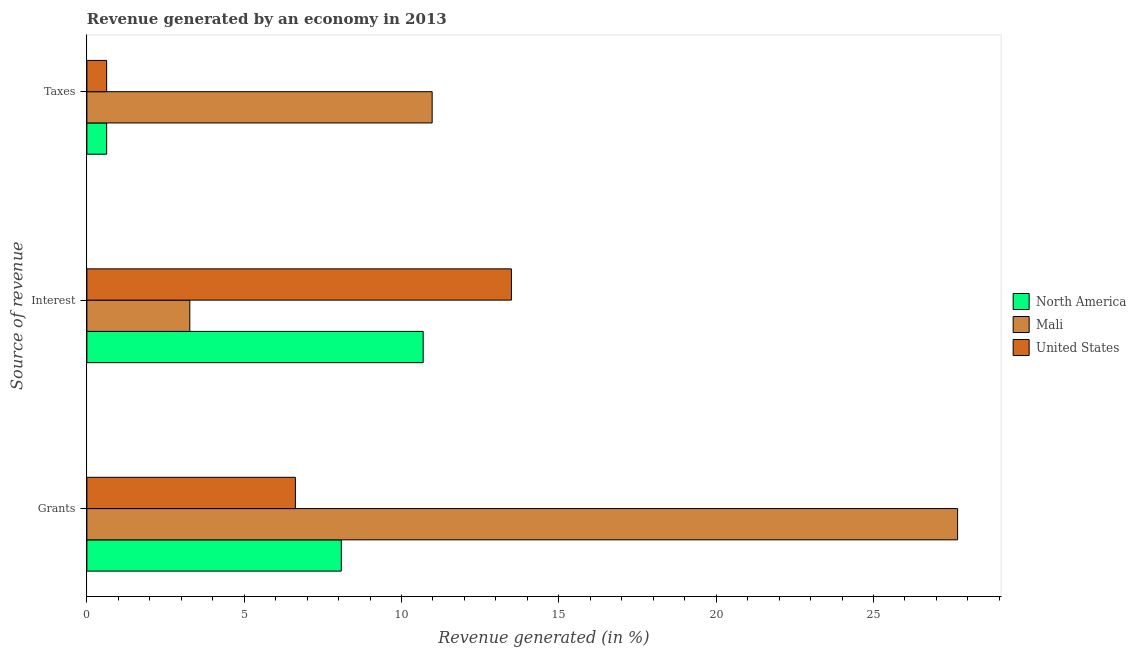Are the number of bars per tick equal to the number of legend labels?
Your answer should be compact. Yes. What is the label of the 1st group of bars from the top?
Ensure brevity in your answer.  Taxes. What is the percentage of revenue generated by grants in Mali?
Offer a very short reply. 27.67. Across all countries, what is the maximum percentage of revenue generated by interest?
Your answer should be compact. 13.49. Across all countries, what is the minimum percentage of revenue generated by interest?
Provide a succinct answer. 3.27. In which country was the percentage of revenue generated by interest maximum?
Make the answer very short. United States. What is the total percentage of revenue generated by interest in the graph?
Give a very brief answer. 27.45. What is the difference between the percentage of revenue generated by taxes in North America and that in United States?
Your answer should be very brief. 0. What is the difference between the percentage of revenue generated by interest in North America and the percentage of revenue generated by grants in Mali?
Your answer should be compact. -16.99. What is the average percentage of revenue generated by grants per country?
Give a very brief answer. 14.13. What is the difference between the percentage of revenue generated by interest and percentage of revenue generated by taxes in North America?
Make the answer very short. 10.06. In how many countries, is the percentage of revenue generated by grants greater than 28 %?
Your answer should be very brief. 0. What is the ratio of the percentage of revenue generated by grants in North America to that in Mali?
Make the answer very short. 0.29. What is the difference between the highest and the second highest percentage of revenue generated by interest?
Make the answer very short. 2.8. What is the difference between the highest and the lowest percentage of revenue generated by grants?
Your answer should be compact. 21.05. In how many countries, is the percentage of revenue generated by grants greater than the average percentage of revenue generated by grants taken over all countries?
Provide a short and direct response. 1. Is the sum of the percentage of revenue generated by grants in North America and Mali greater than the maximum percentage of revenue generated by taxes across all countries?
Keep it short and to the point. Yes. What does the 3rd bar from the top in Taxes represents?
Give a very brief answer. North America. What does the 2nd bar from the bottom in Interest represents?
Your answer should be very brief. Mali. How many bars are there?
Provide a short and direct response. 9. Are all the bars in the graph horizontal?
Your answer should be very brief. Yes. What is the difference between two consecutive major ticks on the X-axis?
Your response must be concise. 5. Are the values on the major ticks of X-axis written in scientific E-notation?
Provide a short and direct response. No. Does the graph contain any zero values?
Your answer should be very brief. No. Does the graph contain grids?
Provide a short and direct response. No. Where does the legend appear in the graph?
Keep it short and to the point. Center right. How many legend labels are there?
Make the answer very short. 3. How are the legend labels stacked?
Your response must be concise. Vertical. What is the title of the graph?
Your response must be concise. Revenue generated by an economy in 2013. What is the label or title of the X-axis?
Your answer should be very brief. Revenue generated (in %). What is the label or title of the Y-axis?
Provide a short and direct response. Source of revenue. What is the Revenue generated (in %) in North America in Grants?
Make the answer very short. 8.09. What is the Revenue generated (in %) of Mali in Grants?
Provide a succinct answer. 27.67. What is the Revenue generated (in %) of United States in Grants?
Keep it short and to the point. 6.63. What is the Revenue generated (in %) in North America in Interest?
Make the answer very short. 10.69. What is the Revenue generated (in %) of Mali in Interest?
Your answer should be very brief. 3.27. What is the Revenue generated (in %) of United States in Interest?
Keep it short and to the point. 13.49. What is the Revenue generated (in %) of North America in Taxes?
Your response must be concise. 0.63. What is the Revenue generated (in %) in Mali in Taxes?
Ensure brevity in your answer.  10.97. What is the Revenue generated (in %) of United States in Taxes?
Make the answer very short. 0.63. Across all Source of revenue, what is the maximum Revenue generated (in %) in North America?
Offer a terse response. 10.69. Across all Source of revenue, what is the maximum Revenue generated (in %) of Mali?
Your answer should be compact. 27.67. Across all Source of revenue, what is the maximum Revenue generated (in %) in United States?
Offer a terse response. 13.49. Across all Source of revenue, what is the minimum Revenue generated (in %) of North America?
Your response must be concise. 0.63. Across all Source of revenue, what is the minimum Revenue generated (in %) of Mali?
Provide a succinct answer. 3.27. Across all Source of revenue, what is the minimum Revenue generated (in %) of United States?
Provide a short and direct response. 0.63. What is the total Revenue generated (in %) of North America in the graph?
Give a very brief answer. 19.4. What is the total Revenue generated (in %) in Mali in the graph?
Provide a short and direct response. 41.92. What is the total Revenue generated (in %) of United States in the graph?
Your answer should be very brief. 20.75. What is the difference between the Revenue generated (in %) of North America in Grants and that in Interest?
Offer a terse response. -2.6. What is the difference between the Revenue generated (in %) of Mali in Grants and that in Interest?
Your answer should be very brief. 24.4. What is the difference between the Revenue generated (in %) of United States in Grants and that in Interest?
Offer a very short reply. -6.87. What is the difference between the Revenue generated (in %) of North America in Grants and that in Taxes?
Provide a short and direct response. 7.46. What is the difference between the Revenue generated (in %) in Mali in Grants and that in Taxes?
Your answer should be very brief. 16.7. What is the difference between the Revenue generated (in %) of United States in Grants and that in Taxes?
Offer a very short reply. 6. What is the difference between the Revenue generated (in %) in North America in Interest and that in Taxes?
Your answer should be compact. 10.06. What is the difference between the Revenue generated (in %) of Mali in Interest and that in Taxes?
Ensure brevity in your answer.  -7.7. What is the difference between the Revenue generated (in %) of United States in Interest and that in Taxes?
Keep it short and to the point. 12.86. What is the difference between the Revenue generated (in %) in North America in Grants and the Revenue generated (in %) in Mali in Interest?
Your answer should be very brief. 4.81. What is the difference between the Revenue generated (in %) of North America in Grants and the Revenue generated (in %) of United States in Interest?
Your response must be concise. -5.41. What is the difference between the Revenue generated (in %) in Mali in Grants and the Revenue generated (in %) in United States in Interest?
Your response must be concise. 14.18. What is the difference between the Revenue generated (in %) in North America in Grants and the Revenue generated (in %) in Mali in Taxes?
Your answer should be compact. -2.89. What is the difference between the Revenue generated (in %) of North America in Grants and the Revenue generated (in %) of United States in Taxes?
Your answer should be compact. 7.46. What is the difference between the Revenue generated (in %) in Mali in Grants and the Revenue generated (in %) in United States in Taxes?
Give a very brief answer. 27.05. What is the difference between the Revenue generated (in %) in North America in Interest and the Revenue generated (in %) in Mali in Taxes?
Keep it short and to the point. -0.28. What is the difference between the Revenue generated (in %) of North America in Interest and the Revenue generated (in %) of United States in Taxes?
Keep it short and to the point. 10.06. What is the difference between the Revenue generated (in %) in Mali in Interest and the Revenue generated (in %) in United States in Taxes?
Keep it short and to the point. 2.64. What is the average Revenue generated (in %) of North America per Source of revenue?
Your answer should be compact. 6.47. What is the average Revenue generated (in %) in Mali per Source of revenue?
Your answer should be very brief. 13.97. What is the average Revenue generated (in %) in United States per Source of revenue?
Your answer should be compact. 6.92. What is the difference between the Revenue generated (in %) in North America and Revenue generated (in %) in Mali in Grants?
Provide a short and direct response. -19.59. What is the difference between the Revenue generated (in %) of North America and Revenue generated (in %) of United States in Grants?
Your response must be concise. 1.46. What is the difference between the Revenue generated (in %) of Mali and Revenue generated (in %) of United States in Grants?
Provide a succinct answer. 21.05. What is the difference between the Revenue generated (in %) in North America and Revenue generated (in %) in Mali in Interest?
Your answer should be very brief. 7.42. What is the difference between the Revenue generated (in %) of North America and Revenue generated (in %) of United States in Interest?
Offer a terse response. -2.8. What is the difference between the Revenue generated (in %) of Mali and Revenue generated (in %) of United States in Interest?
Your response must be concise. -10.22. What is the difference between the Revenue generated (in %) of North America and Revenue generated (in %) of Mali in Taxes?
Give a very brief answer. -10.34. What is the difference between the Revenue generated (in %) in Mali and Revenue generated (in %) in United States in Taxes?
Offer a very short reply. 10.34. What is the ratio of the Revenue generated (in %) in North America in Grants to that in Interest?
Provide a succinct answer. 0.76. What is the ratio of the Revenue generated (in %) in Mali in Grants to that in Interest?
Offer a very short reply. 8.46. What is the ratio of the Revenue generated (in %) of United States in Grants to that in Interest?
Provide a succinct answer. 0.49. What is the ratio of the Revenue generated (in %) of North America in Grants to that in Taxes?
Provide a short and direct response. 12.86. What is the ratio of the Revenue generated (in %) in Mali in Grants to that in Taxes?
Your response must be concise. 2.52. What is the ratio of the Revenue generated (in %) in United States in Grants to that in Taxes?
Offer a terse response. 10.54. What is the ratio of the Revenue generated (in %) of North America in Interest to that in Taxes?
Ensure brevity in your answer.  17. What is the ratio of the Revenue generated (in %) of Mali in Interest to that in Taxes?
Keep it short and to the point. 0.3. What is the ratio of the Revenue generated (in %) of United States in Interest to that in Taxes?
Your answer should be very brief. 21.46. What is the difference between the highest and the second highest Revenue generated (in %) in North America?
Offer a terse response. 2.6. What is the difference between the highest and the second highest Revenue generated (in %) in Mali?
Your response must be concise. 16.7. What is the difference between the highest and the second highest Revenue generated (in %) in United States?
Your answer should be very brief. 6.87. What is the difference between the highest and the lowest Revenue generated (in %) in North America?
Offer a very short reply. 10.06. What is the difference between the highest and the lowest Revenue generated (in %) of Mali?
Provide a short and direct response. 24.4. What is the difference between the highest and the lowest Revenue generated (in %) of United States?
Keep it short and to the point. 12.86. 